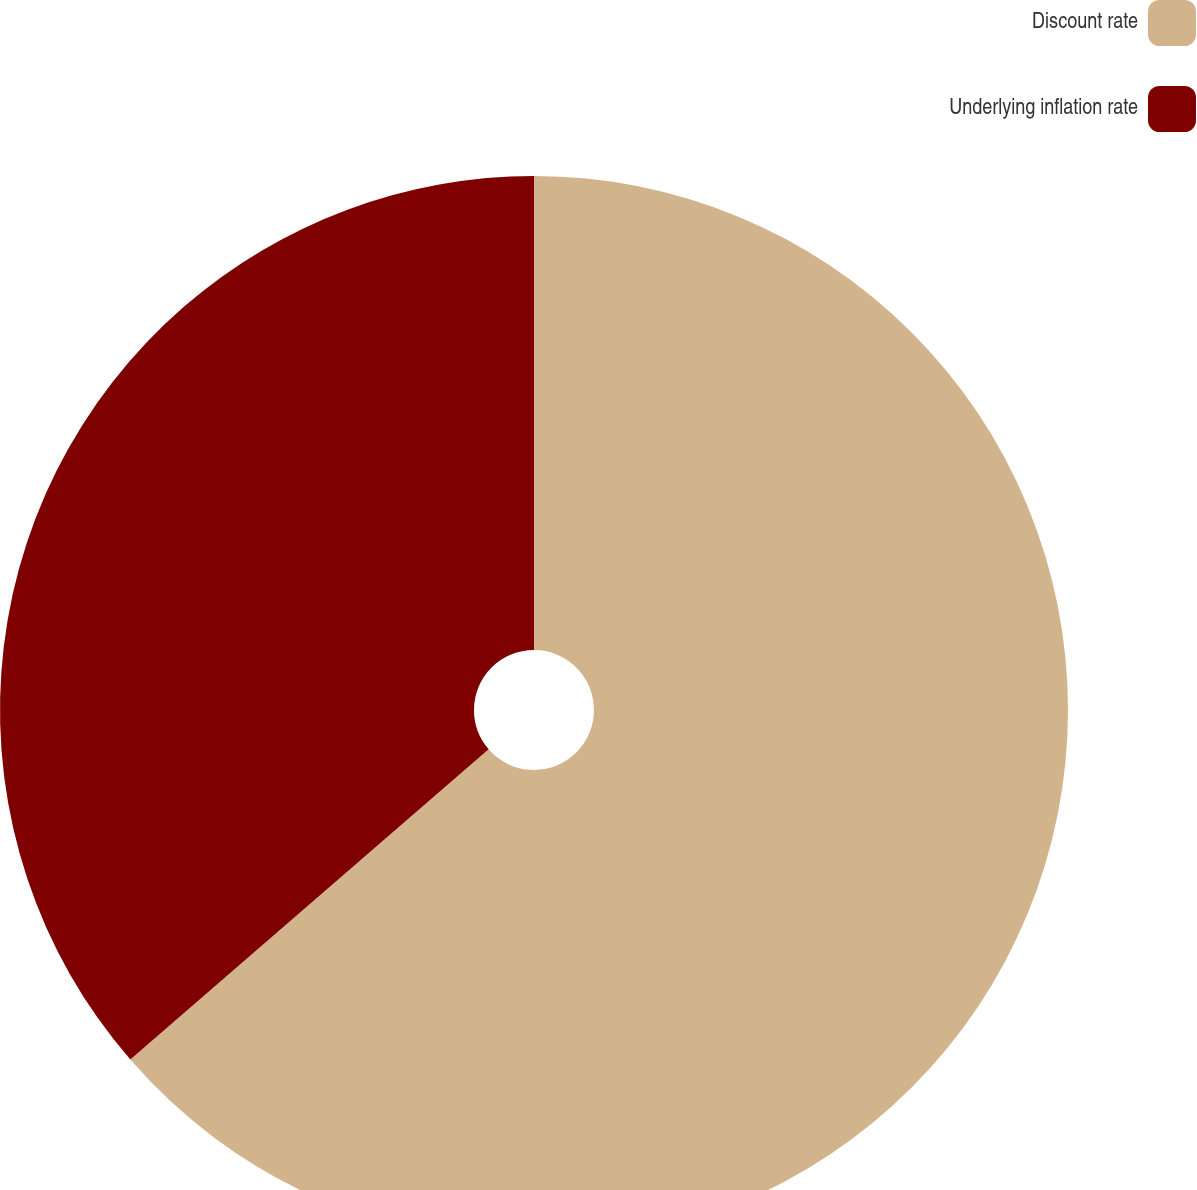<chart> <loc_0><loc_0><loc_500><loc_500><pie_chart><fcel>Discount rate<fcel>Underlying inflation rate<nl><fcel>63.64%<fcel>36.36%<nl></chart> 